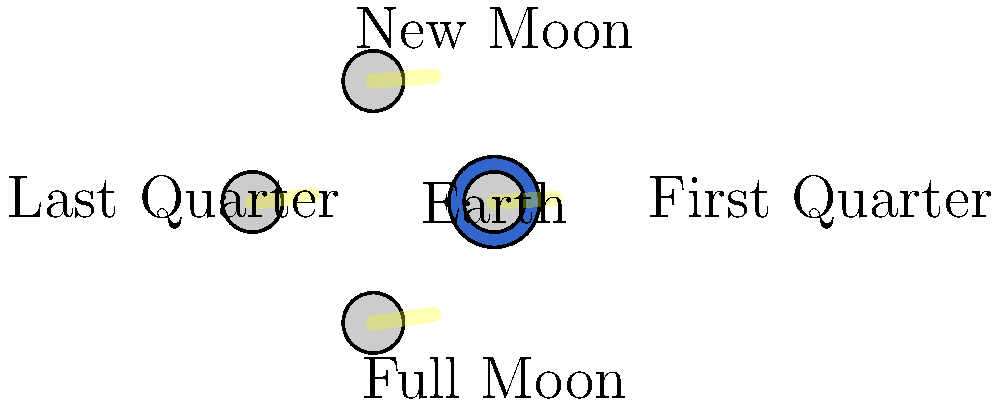As a store assistant educating customers about local produce, you often discuss how the Moon's phases affect farming practices. Looking at the diagram, which phase of the Moon would provide the most nighttime illumination for farmers working late in their fields? To answer this question, let's analyze the Moon's phases and their impact on nighttime illumination:

1. The diagram shows four main phases of the Moon as seen from Earth:
   - New Moon (top)
   - First Quarter (right)
   - Full Moon (bottom)
   - Last Quarter (left)

2. The amount of illumination depends on how much of the Moon's sunlit surface is visible from Earth:
   - New Moon: The sunlit side faces away from Earth, providing no illumination.
   - First Quarter: Half of the visible surface is illuminated, providing moderate light.
   - Full Moon: The entire visible surface is illuminated, providing maximum light.
   - Last Quarter: Half of the visible surface is illuminated, providing moderate light.

3. The Full Moon phase occurs when the Earth is between the Sun and the Moon, allowing the entire sunlit face of the Moon to be visible from Earth.

4. During a Full Moon, the Moon rises at sunset and sets at sunrise, providing illumination throughout the night.

5. Farmers working late in their fields would benefit most from the increased visibility during a Full Moon, as it offers the brightest and longest-lasting natural nighttime illumination.

Therefore, the Full Moon phase would provide the most nighttime illumination for farmers working late in their fields.
Answer: Full Moon 